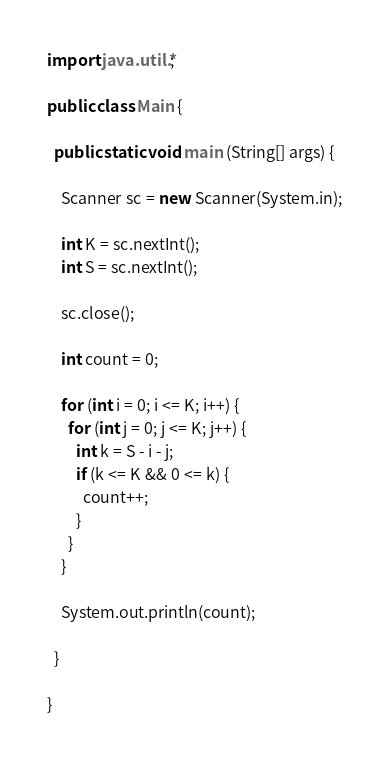Convert code to text. <code><loc_0><loc_0><loc_500><loc_500><_Java_>import java.util.*;

public class Main {

  public static void main (String[] args) {

    Scanner sc = new Scanner(System.in);

    int K = sc.nextInt();
    int S = sc.nextInt();

    sc.close();

    int count = 0;

    for (int i = 0; i <= K; i++) {
      for (int j = 0; j <= K; j++) {
        int k = S - i - j;
        if (k <= K && 0 <= k) {
          count++;
        }
      }
    }

    System.out.println(count);

  }

}</code> 